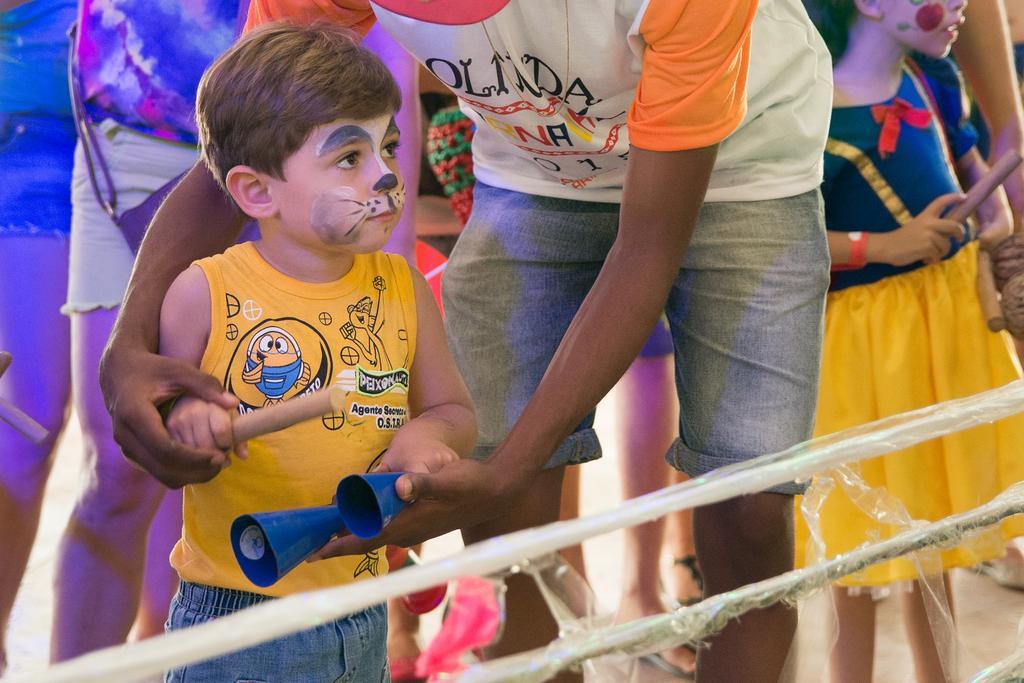Describe this image in one or two sentences. In this image we can see many persons standing on the ground. At the bottom of the image we can see iron rods. 